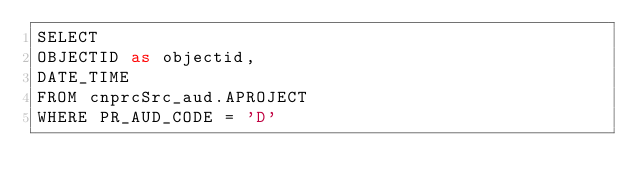Convert code to text. <code><loc_0><loc_0><loc_500><loc_500><_SQL_>SELECT
OBJECTID as objectid,
DATE_TIME
FROM cnprcSrc_aud.APROJECT
WHERE PR_AUD_CODE = 'D'</code> 